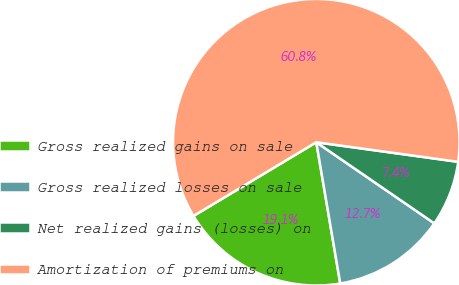Convert chart to OTSL. <chart><loc_0><loc_0><loc_500><loc_500><pie_chart><fcel>Gross realized gains on sale<fcel>Gross realized losses on sale<fcel>Net realized gains (losses) on<fcel>Amortization of premiums on<nl><fcel>19.07%<fcel>12.74%<fcel>7.4%<fcel>60.78%<nl></chart> 